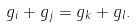<formula> <loc_0><loc_0><loc_500><loc_500>g _ { i } + g _ { j } = g _ { k } + g _ { l } .</formula> 